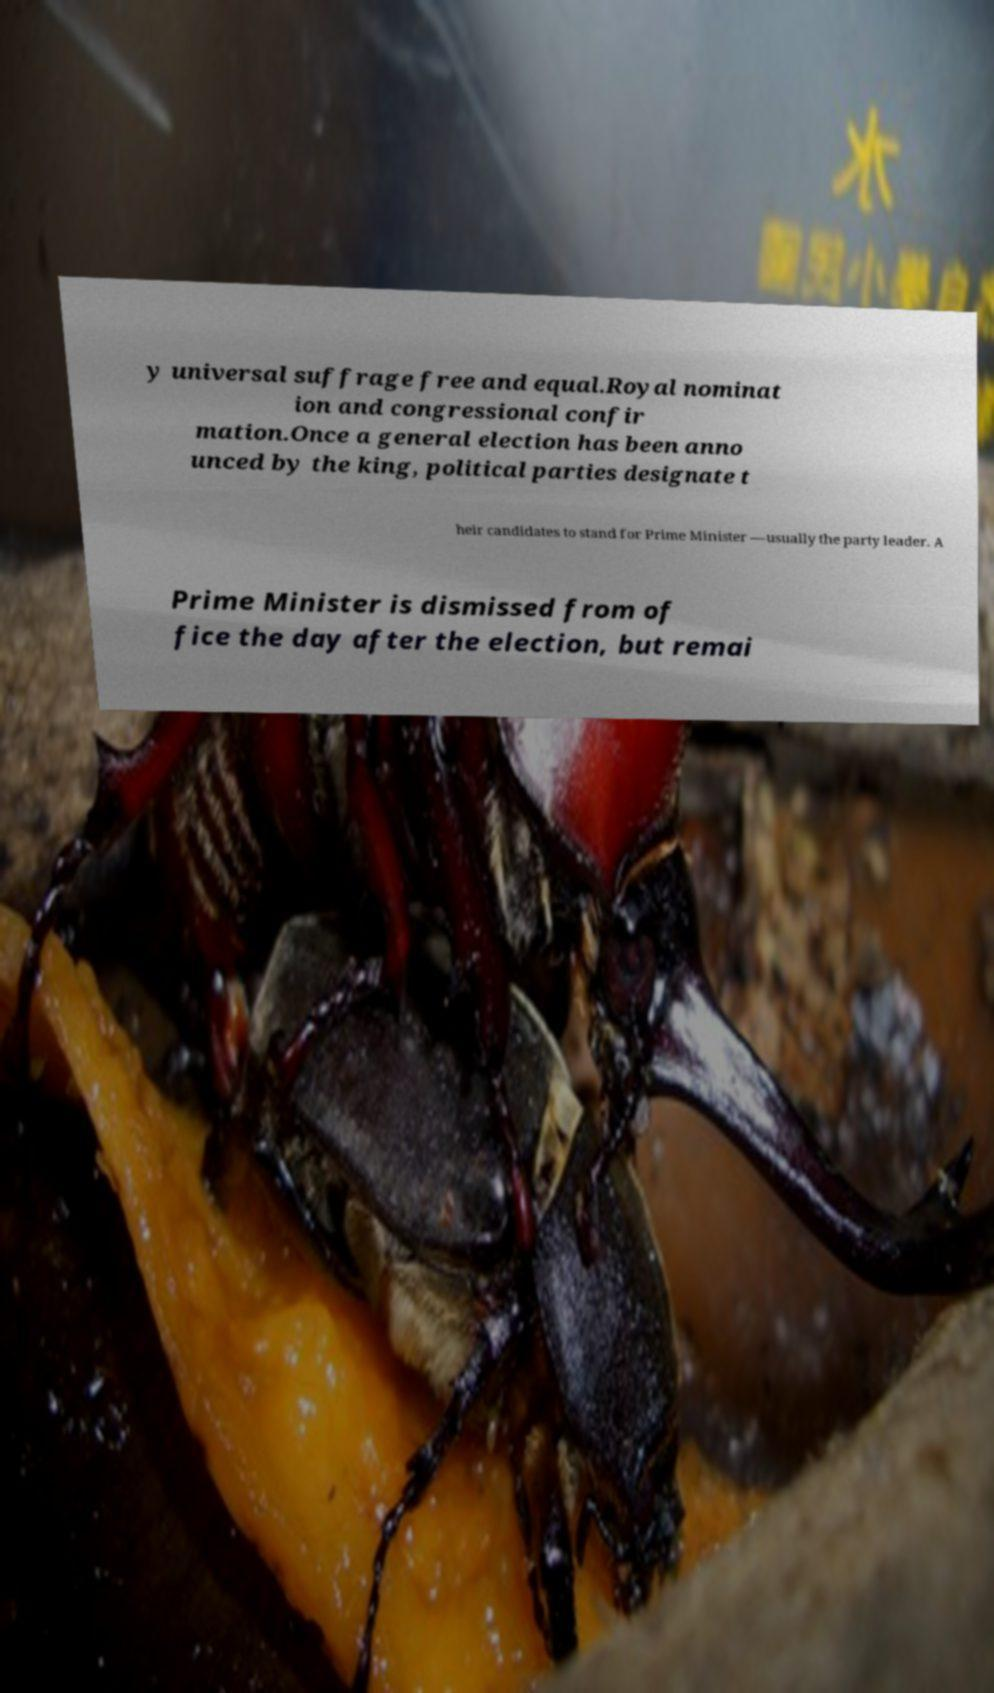I need the written content from this picture converted into text. Can you do that? y universal suffrage free and equal.Royal nominat ion and congressional confir mation.Once a general election has been anno unced by the king, political parties designate t heir candidates to stand for Prime Minister —usually the party leader. A Prime Minister is dismissed from of fice the day after the election, but remai 